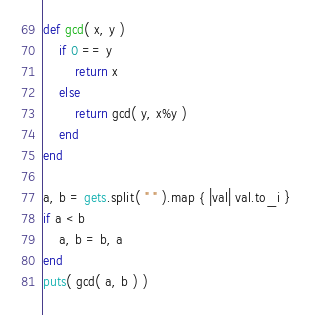Convert code to text. <code><loc_0><loc_0><loc_500><loc_500><_Ruby_>def gcd( x, y )
	if 0 == y
		return x
	else
		return gcd( y, x%y )
	end	
end

a, b = gets.split( " " ).map { |val| val.to_i }
if a < b
	a, b = b, a
end
puts( gcd( a, b ) )</code> 